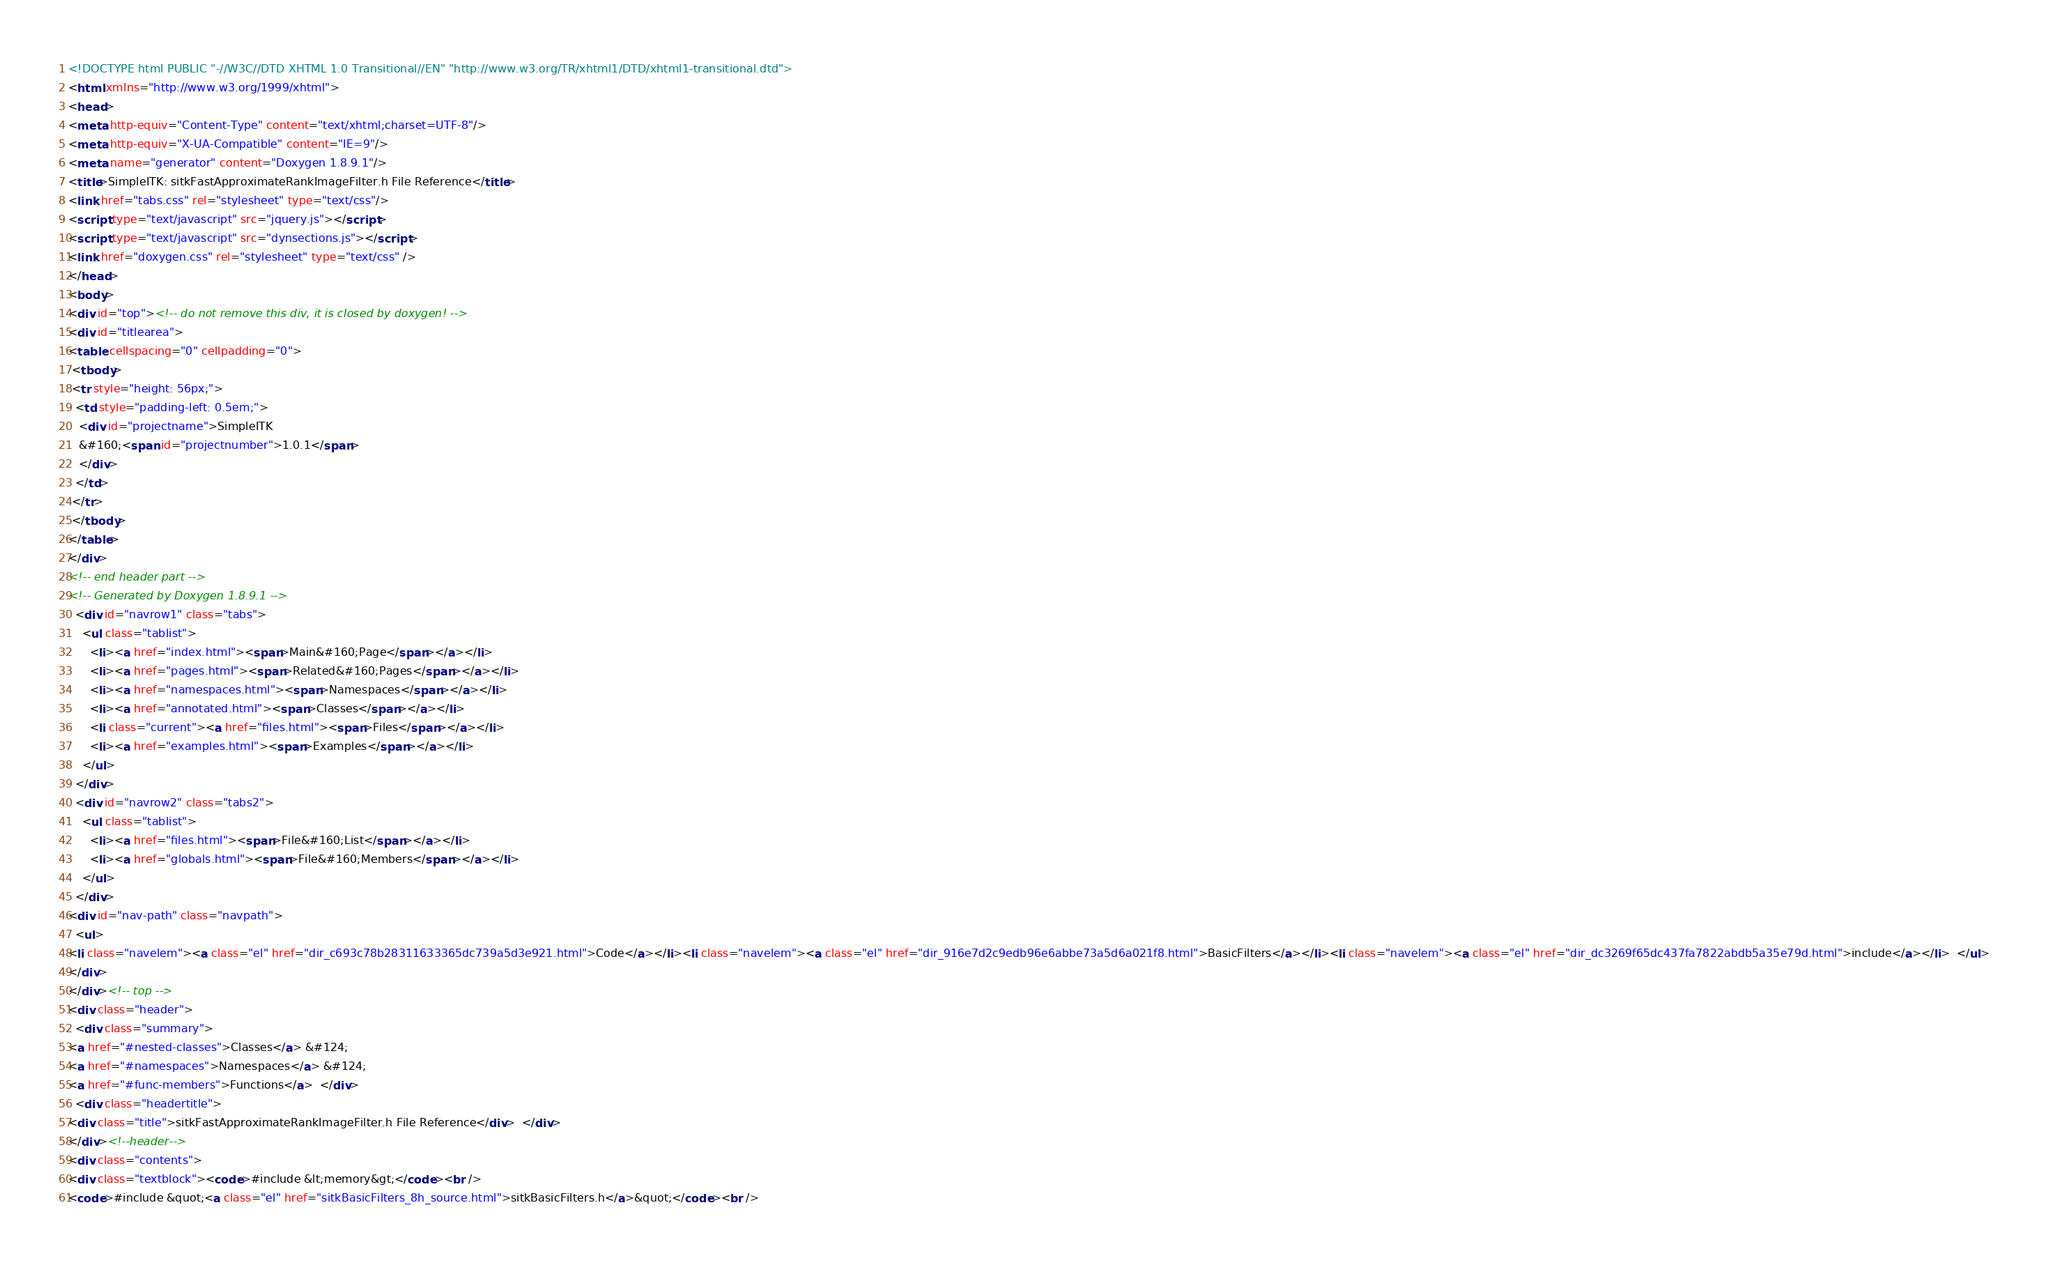<code> <loc_0><loc_0><loc_500><loc_500><_HTML_><!DOCTYPE html PUBLIC "-//W3C//DTD XHTML 1.0 Transitional//EN" "http://www.w3.org/TR/xhtml1/DTD/xhtml1-transitional.dtd">
<html xmlns="http://www.w3.org/1999/xhtml">
<head>
<meta http-equiv="Content-Type" content="text/xhtml;charset=UTF-8"/>
<meta http-equiv="X-UA-Compatible" content="IE=9"/>
<meta name="generator" content="Doxygen 1.8.9.1"/>
<title>SimpleITK: sitkFastApproximateRankImageFilter.h File Reference</title>
<link href="tabs.css" rel="stylesheet" type="text/css"/>
<script type="text/javascript" src="jquery.js"></script>
<script type="text/javascript" src="dynsections.js"></script>
<link href="doxygen.css" rel="stylesheet" type="text/css" />
</head>
<body>
<div id="top"><!-- do not remove this div, it is closed by doxygen! -->
<div id="titlearea">
<table cellspacing="0" cellpadding="0">
 <tbody>
 <tr style="height: 56px;">
  <td style="padding-left: 0.5em;">
   <div id="projectname">SimpleITK
   &#160;<span id="projectnumber">1.0.1</span>
   </div>
  </td>
 </tr>
 </tbody>
</table>
</div>
<!-- end header part -->
<!-- Generated by Doxygen 1.8.9.1 -->
  <div id="navrow1" class="tabs">
    <ul class="tablist">
      <li><a href="index.html"><span>Main&#160;Page</span></a></li>
      <li><a href="pages.html"><span>Related&#160;Pages</span></a></li>
      <li><a href="namespaces.html"><span>Namespaces</span></a></li>
      <li><a href="annotated.html"><span>Classes</span></a></li>
      <li class="current"><a href="files.html"><span>Files</span></a></li>
      <li><a href="examples.html"><span>Examples</span></a></li>
    </ul>
  </div>
  <div id="navrow2" class="tabs2">
    <ul class="tablist">
      <li><a href="files.html"><span>File&#160;List</span></a></li>
      <li><a href="globals.html"><span>File&#160;Members</span></a></li>
    </ul>
  </div>
<div id="nav-path" class="navpath">
  <ul>
<li class="navelem"><a class="el" href="dir_c693c78b28311633365dc739a5d3e921.html">Code</a></li><li class="navelem"><a class="el" href="dir_916e7d2c9edb96e6abbe73a5d6a021f8.html">BasicFilters</a></li><li class="navelem"><a class="el" href="dir_dc3269f65dc437fa7822abdb5a35e79d.html">include</a></li>  </ul>
</div>
</div><!-- top -->
<div class="header">
  <div class="summary">
<a href="#nested-classes">Classes</a> &#124;
<a href="#namespaces">Namespaces</a> &#124;
<a href="#func-members">Functions</a>  </div>
  <div class="headertitle">
<div class="title">sitkFastApproximateRankImageFilter.h File Reference</div>  </div>
</div><!--header-->
<div class="contents">
<div class="textblock"><code>#include &lt;memory&gt;</code><br />
<code>#include &quot;<a class="el" href="sitkBasicFilters_8h_source.html">sitkBasicFilters.h</a>&quot;</code><br /></code> 